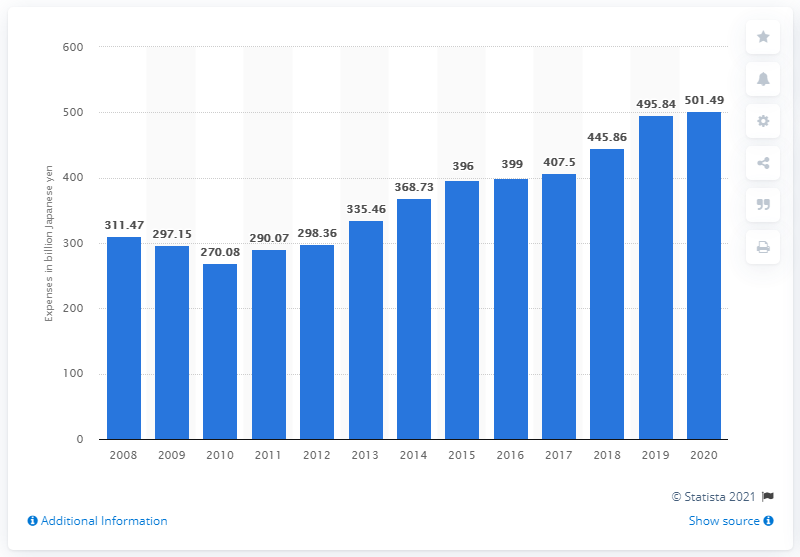Identify some key points in this picture. In 2020, Denso spent a total of 445.86 million Japanese yen on research and development in Japan. Denso spent 501.49 million Japanese yen on research and development costs in 2020. 